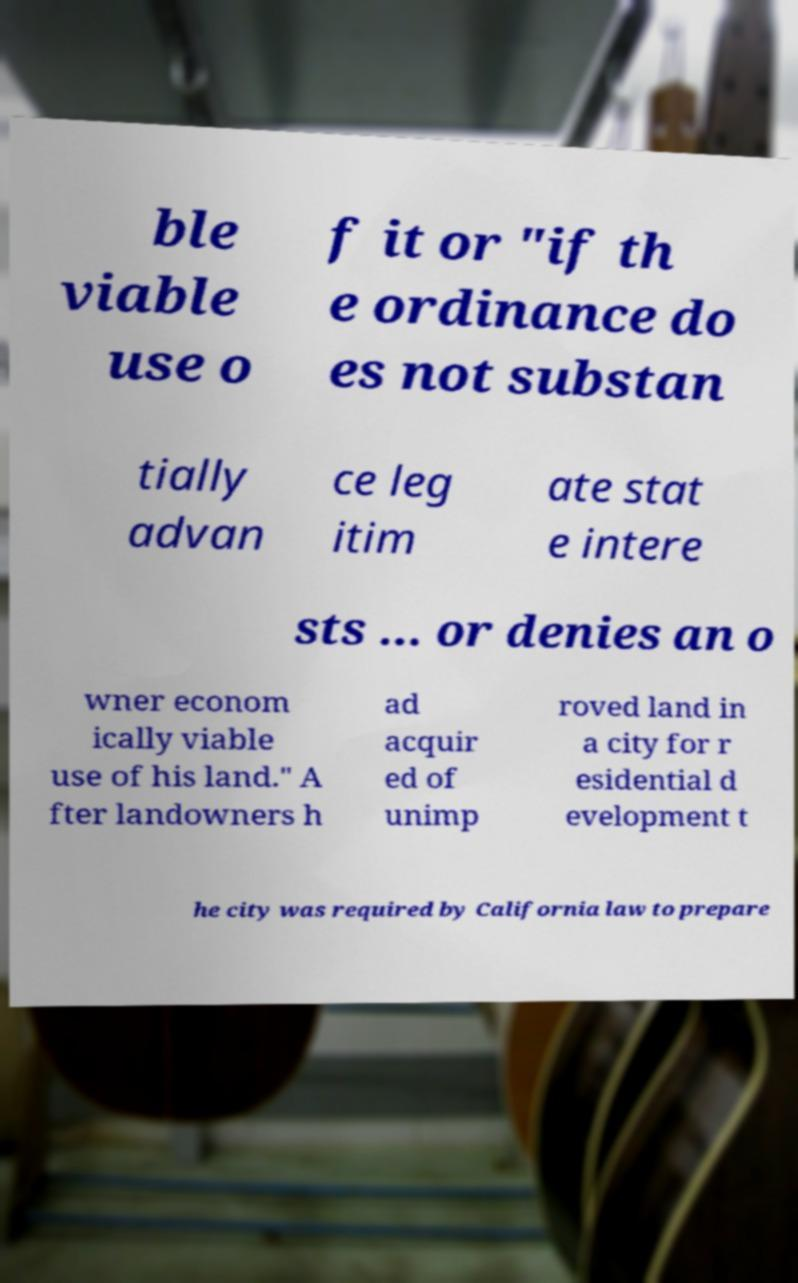I need the written content from this picture converted into text. Can you do that? ble viable use o f it or "if th e ordinance do es not substan tially advan ce leg itim ate stat e intere sts ... or denies an o wner econom ically viable use of his land." A fter landowners h ad acquir ed of unimp roved land in a city for r esidential d evelopment t he city was required by California law to prepare 